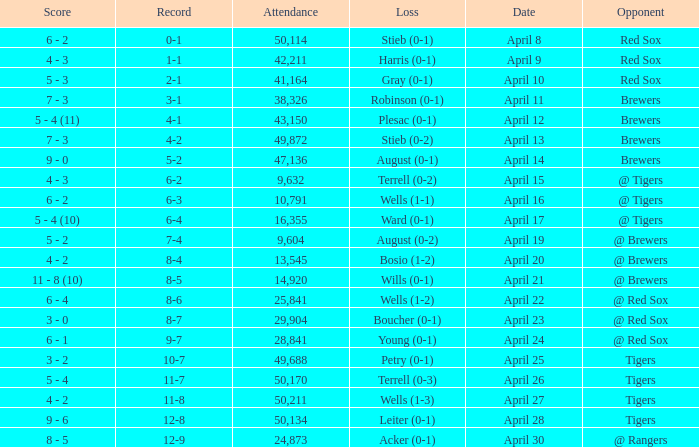What is the largest attendance that has tigers as the opponent and a loss of leiter (0-1)? 50134.0. 